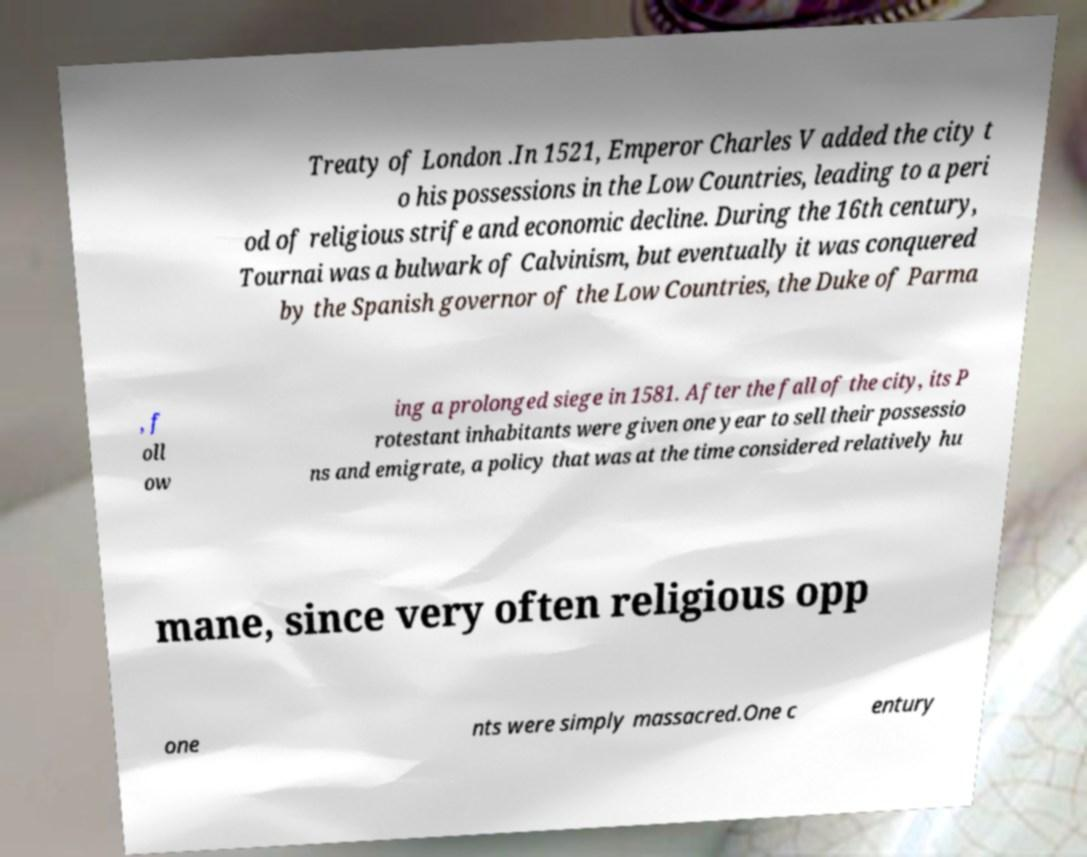Can you accurately transcribe the text from the provided image for me? Treaty of London .In 1521, Emperor Charles V added the city t o his possessions in the Low Countries, leading to a peri od of religious strife and economic decline. During the 16th century, Tournai was a bulwark of Calvinism, but eventually it was conquered by the Spanish governor of the Low Countries, the Duke of Parma , f oll ow ing a prolonged siege in 1581. After the fall of the city, its P rotestant inhabitants were given one year to sell their possessio ns and emigrate, a policy that was at the time considered relatively hu mane, since very often religious opp one nts were simply massacred.One c entury 